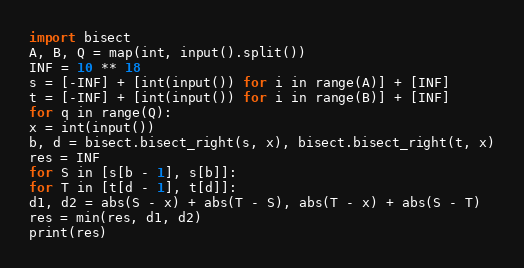<code> <loc_0><loc_0><loc_500><loc_500><_Python_>import bisect
A, B, Q = map(int, input().split())
INF = 10 ** 18
s = [-INF] + [int(input()) for i in range(A)] + [INF]
t = [-INF] + [int(input()) for i in range(B)] + [INF]
for q in range(Q):
x = int(input())
b, d = bisect.bisect_right(s, x), bisect.bisect_right(t, x)
res = INF
for S in [s[b - 1], s[b]]:
for T in [t[d - 1], t[d]]:
d1, d2 = abs(S - x) + abs(T - S), abs(T - x) + abs(S - T)
res = min(res, d1, d2)
print(res)</code> 